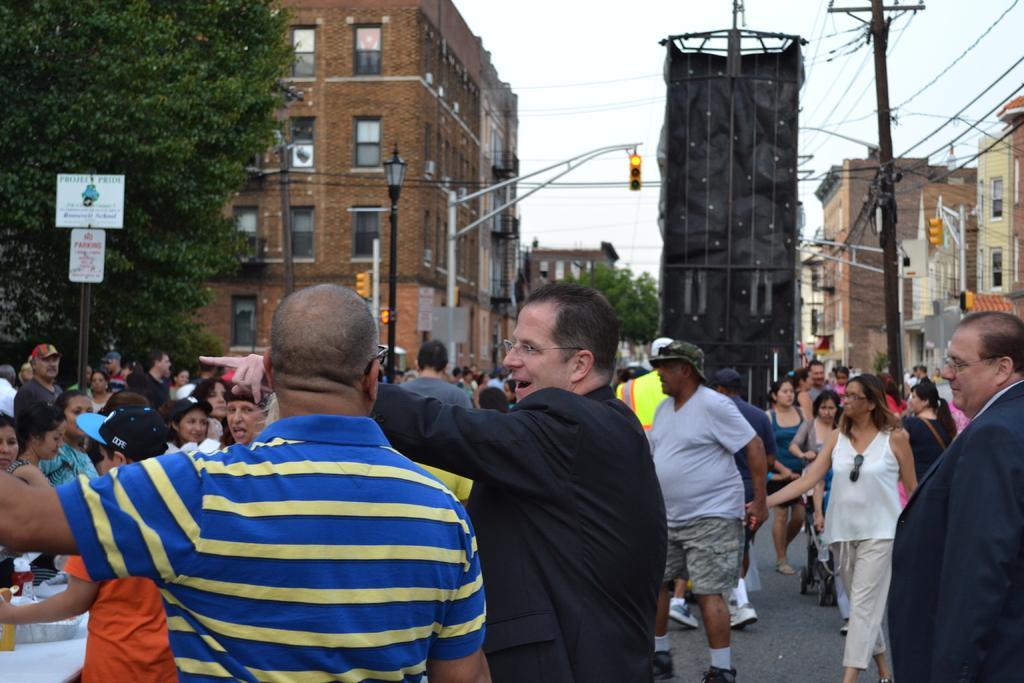Could you give a brief overview of what you see in this image? In this picture we can see many people on the path. There are traffic signals, wires, a tree and a streetlight. Few buildings are visible in the background. 